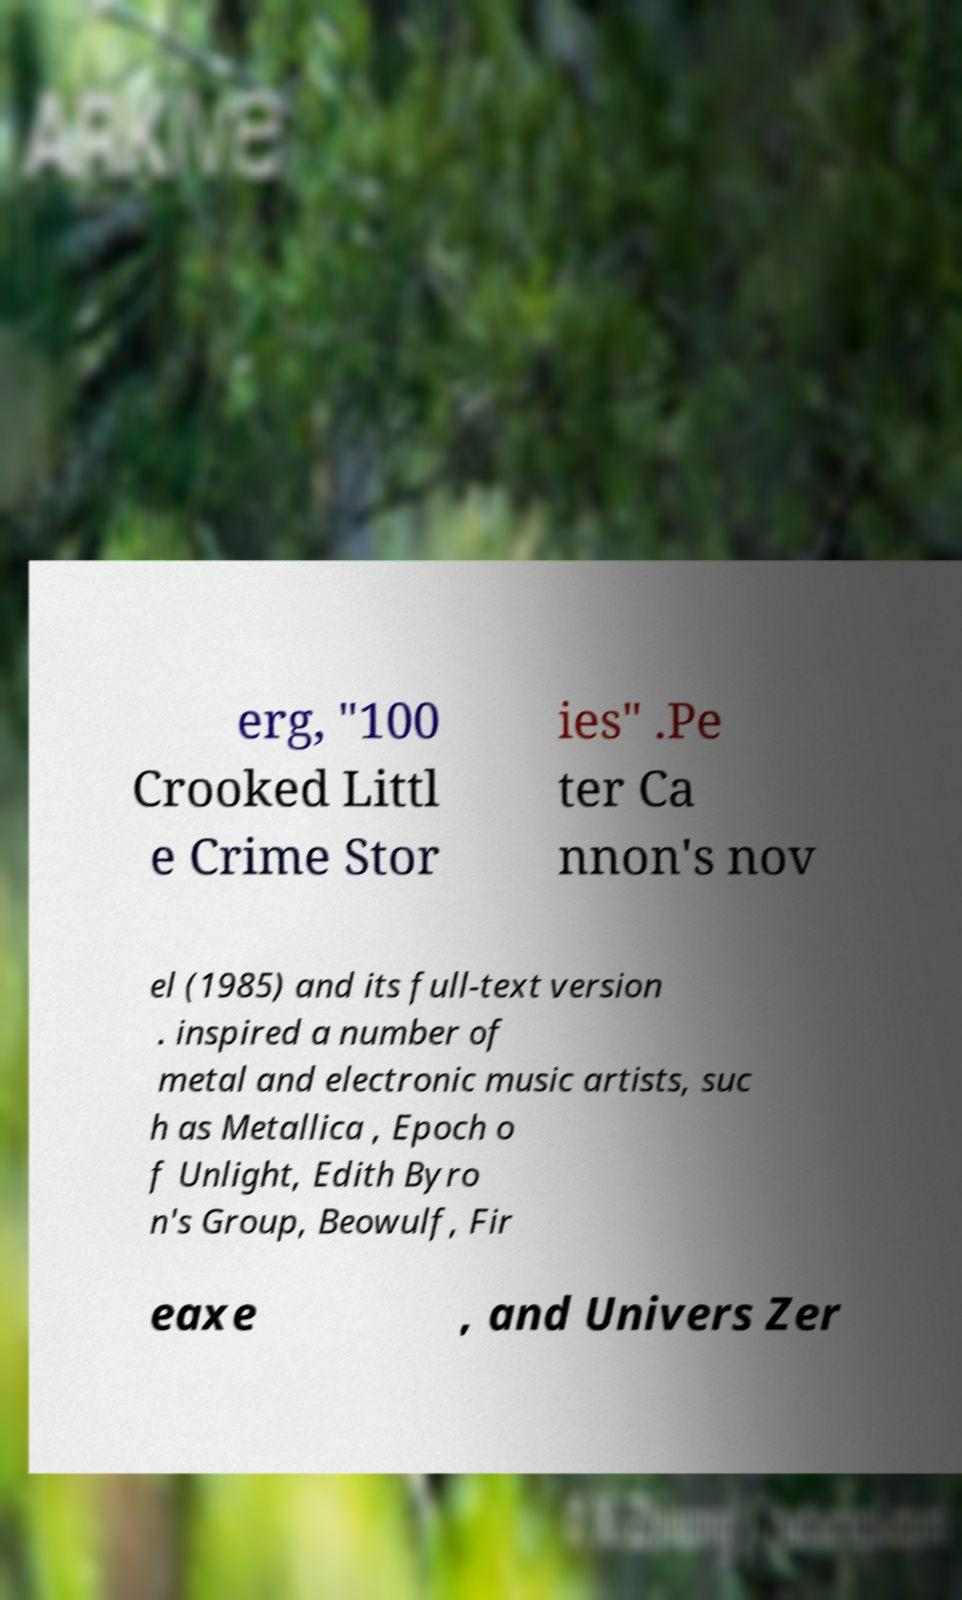Could you assist in decoding the text presented in this image and type it out clearly? erg, "100 Crooked Littl e Crime Stor ies" .Pe ter Ca nnon's nov el (1985) and its full-text version . inspired a number of metal and electronic music artists, suc h as Metallica , Epoch o f Unlight, Edith Byro n's Group, Beowulf, Fir eaxe , and Univers Zer 